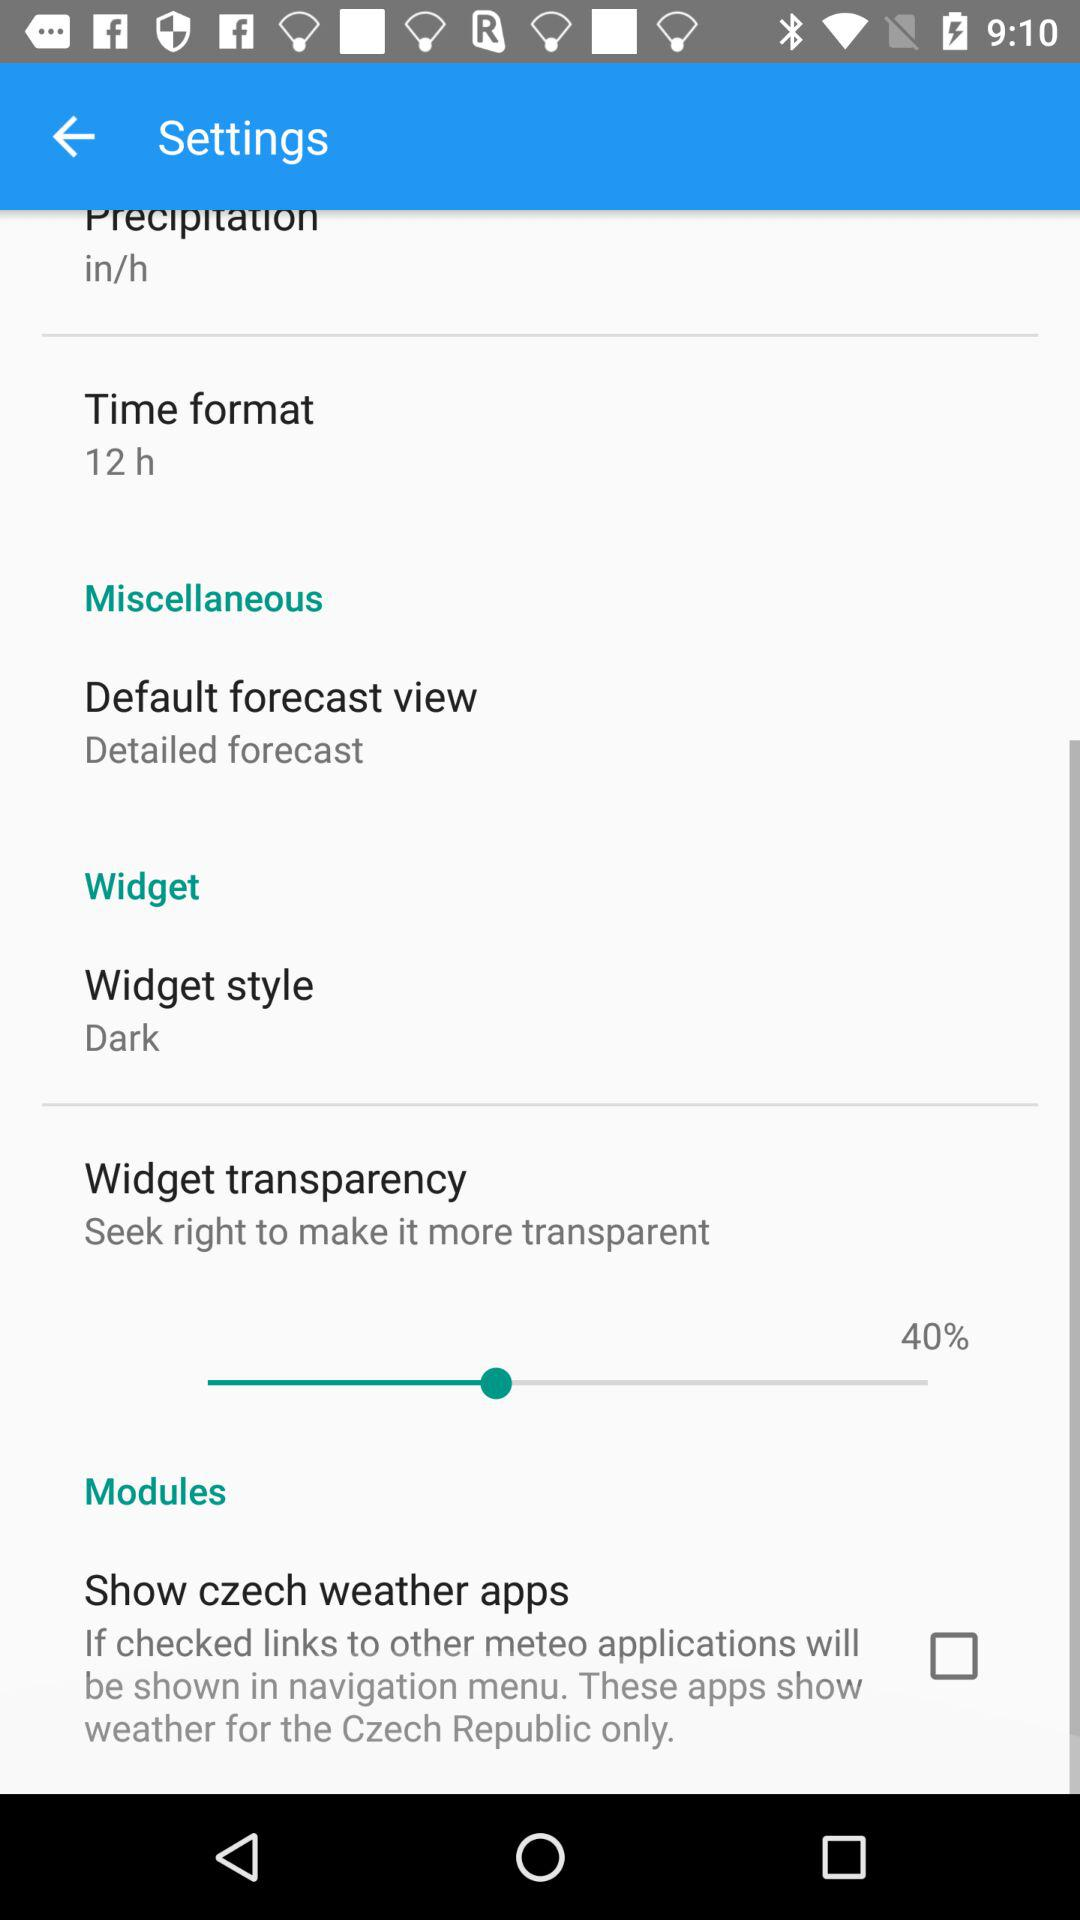What's the widget style? The widget style is dark. 